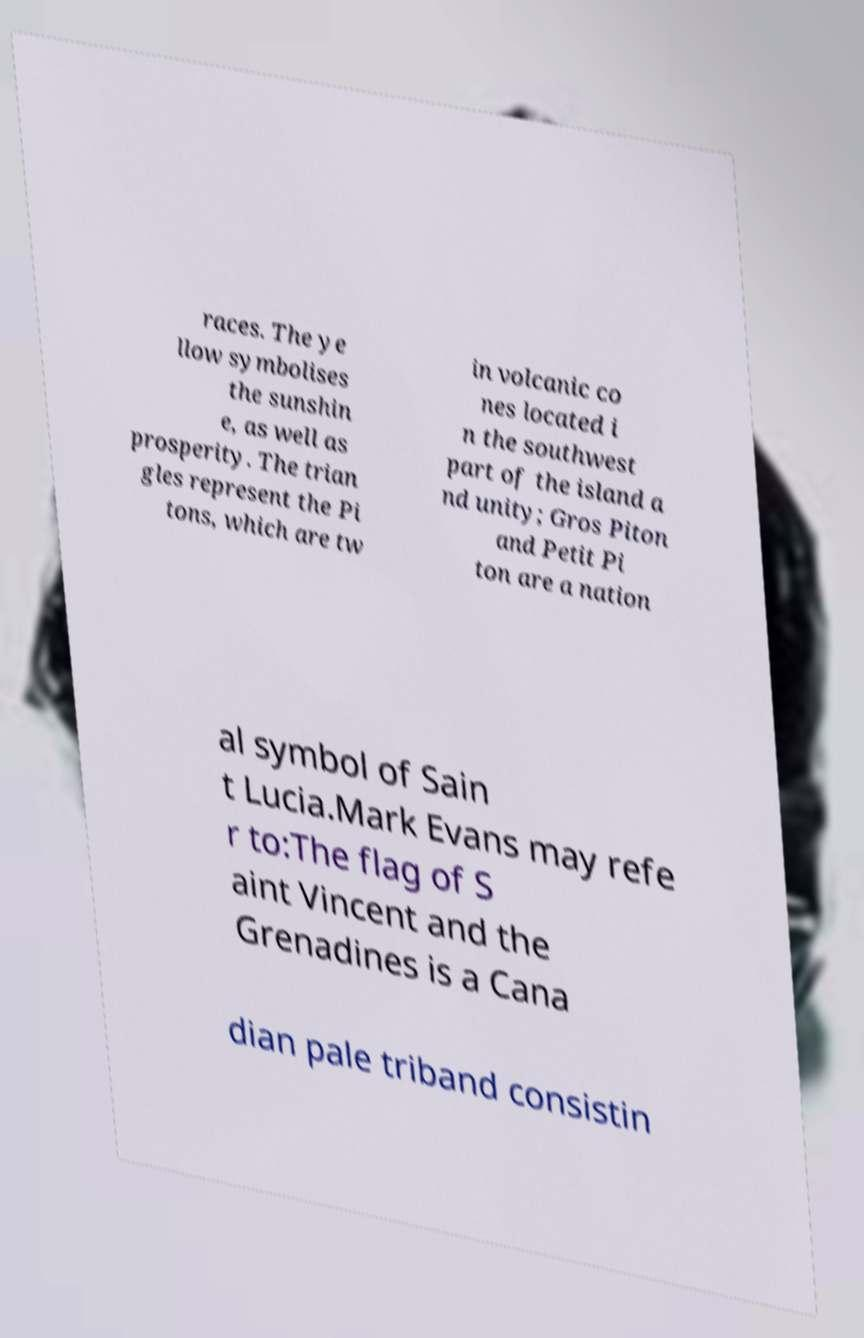There's text embedded in this image that I need extracted. Can you transcribe it verbatim? races. The ye llow symbolises the sunshin e, as well as prosperity. The trian gles represent the Pi tons, which are tw in volcanic co nes located i n the southwest part of the island a nd unity; Gros Piton and Petit Pi ton are a nation al symbol of Sain t Lucia.Mark Evans may refe r to:The flag of S aint Vincent and the Grenadines is a Cana dian pale triband consistin 